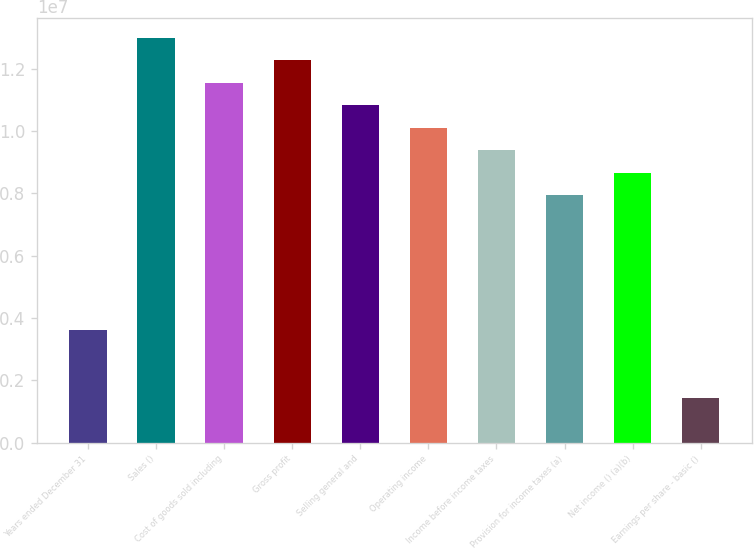Convert chart. <chart><loc_0><loc_0><loc_500><loc_500><bar_chart><fcel>Years ended December 31<fcel>Sales ()<fcel>Cost of goods sold including<fcel>Gross profit<fcel>Selling general and<fcel>Operating income<fcel>Income before income taxes<fcel>Provision for income taxes (a)<fcel>Net income () (a)(b)<fcel>Earnings per share - basic ()<nl><fcel>3.60804e+06<fcel>1.29889e+07<fcel>1.15457e+07<fcel>1.22673e+07<fcel>1.08241e+07<fcel>1.01025e+07<fcel>9.3809e+06<fcel>7.93769e+06<fcel>8.6593e+06<fcel>1.44322e+06<nl></chart> 